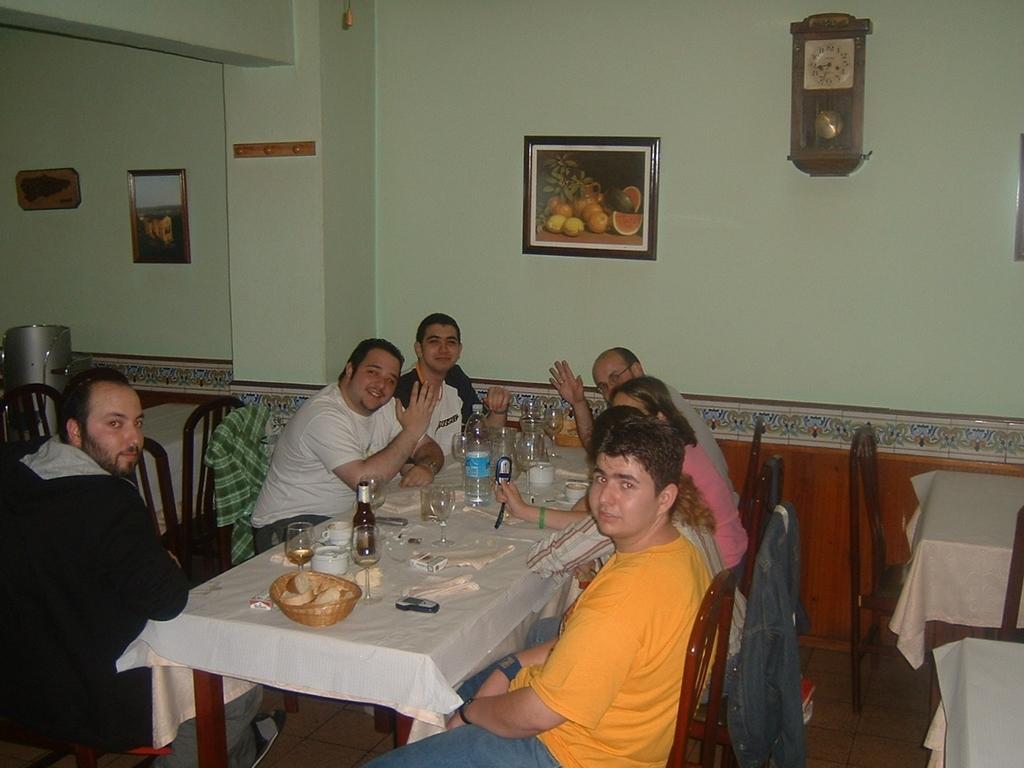Can you describe this image briefly? As we can see in the image there is a wall, photo frame, clock, few people sitting on chairs and there is a table. On table there is a basket, glass, bottles and plate. 